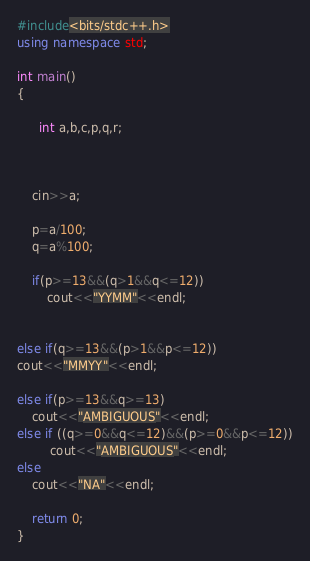<code> <loc_0><loc_0><loc_500><loc_500><_C++_>#include<bits/stdc++.h>
using namespace std;

int main()
{

      int a,b,c,p,q,r;



    cin>>a;

    p=a/100;
    q=a%100;

    if(p>=13&&(q>1&&q<=12))
        cout<<"YYMM"<<endl;


else if(q>=13&&(p>1&&p<=12))
cout<<"MMYY"<<endl;

else if(p>=13&&q>=13)
    cout<<"AMBIGUOUS"<<endl;
else if ((q>=0&&q<=12)&&(p>=0&&p<=12))
         cout<<"AMBIGUOUS"<<endl;
else
    cout<<"NA"<<endl;

    return 0;
}</code> 